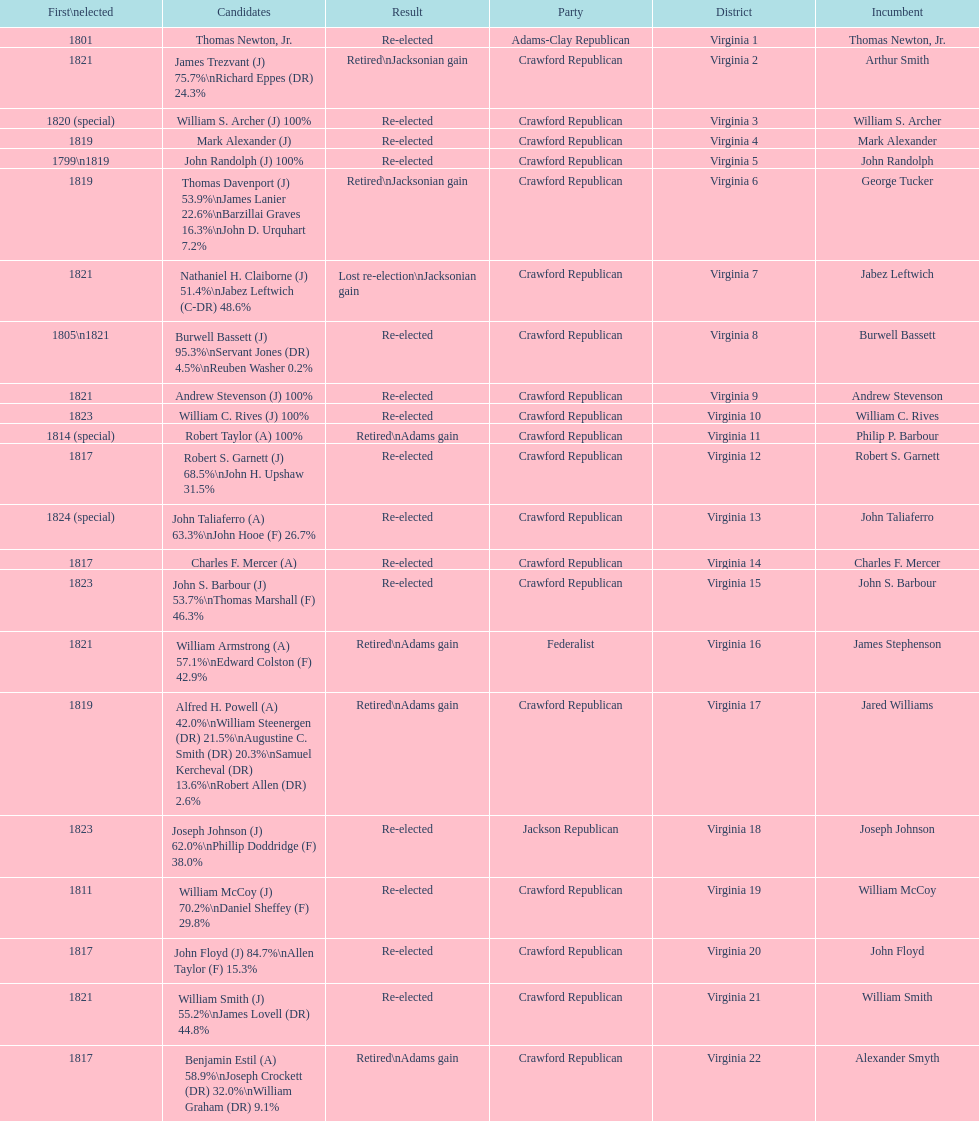Tell me the number of people first elected in 1817. 4. 